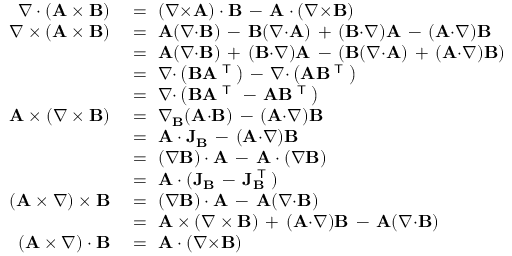<formula> <loc_0><loc_0><loc_500><loc_500>{ \begin{array} { r l } { \nabla \cdot ( A \times B ) } & { \ = \ ( \nabla { \times } A ) \cdot B \, - \, A \cdot ( \nabla { \times } B ) } \\ { \nabla \times ( A \times B ) } & { \ = \ A ( \nabla { \cdot } B ) \, - \, B ( \nabla { \cdot } A ) \, + \, ( B { \cdot } \nabla ) A \, - \, ( A { \cdot } \nabla ) B } \\ & { \ = \ A ( \nabla { \cdot } B ) \, + \, ( B { \cdot } \nabla ) A \, - \, ( B ( \nabla { \cdot } A ) \, + \, ( A { \cdot } \nabla ) B ) } \\ & { \ = \ \nabla { \cdot } \left ( B A ^ { T } \right ) \, - \, \nabla { \cdot } \left ( A B ^ { T } \right ) } \\ & { \ = \ \nabla { \cdot } \left ( B A ^ { T } \, - \, A B ^ { T } \right ) } \\ { A \times ( \nabla \times B ) } & { \ = \ \nabla _ { B } ( A { \cdot } B ) \, - \, ( A { \cdot } \nabla ) B } \\ & { \ = \ A \cdot J _ { B } \, - \, ( A { \cdot } \nabla ) B } \\ & { \ = \ ( \nabla B ) \cdot A \, - \, A \cdot ( \nabla B ) } \\ & { \ = \ A \cdot ( J _ { B } \, - \, J _ { B } ^ { T } ) } \\ { ( A \times \nabla ) \times B } & { \ = \ ( \nabla B ) \cdot A \, - \, A ( \nabla { \cdot } B ) } \\ & { \ = \ A \times ( \nabla \times B ) \, + \, ( A { \cdot } \nabla ) B \, - \, A ( \nabla { \cdot } B ) } \\ { ( A \times \nabla ) \cdot B } & { \ = \ A \cdot ( \nabla { \times } B ) } \end{array} }</formula> 